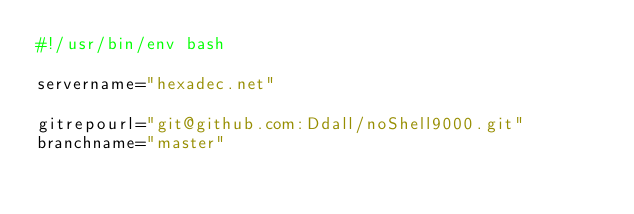<code> <loc_0><loc_0><loc_500><loc_500><_Bash_>#!/usr/bin/env bash

servername="hexadec.net"

gitrepourl="git@github.com:Ddall/noShell9000.git"
branchname="master"
</code> 